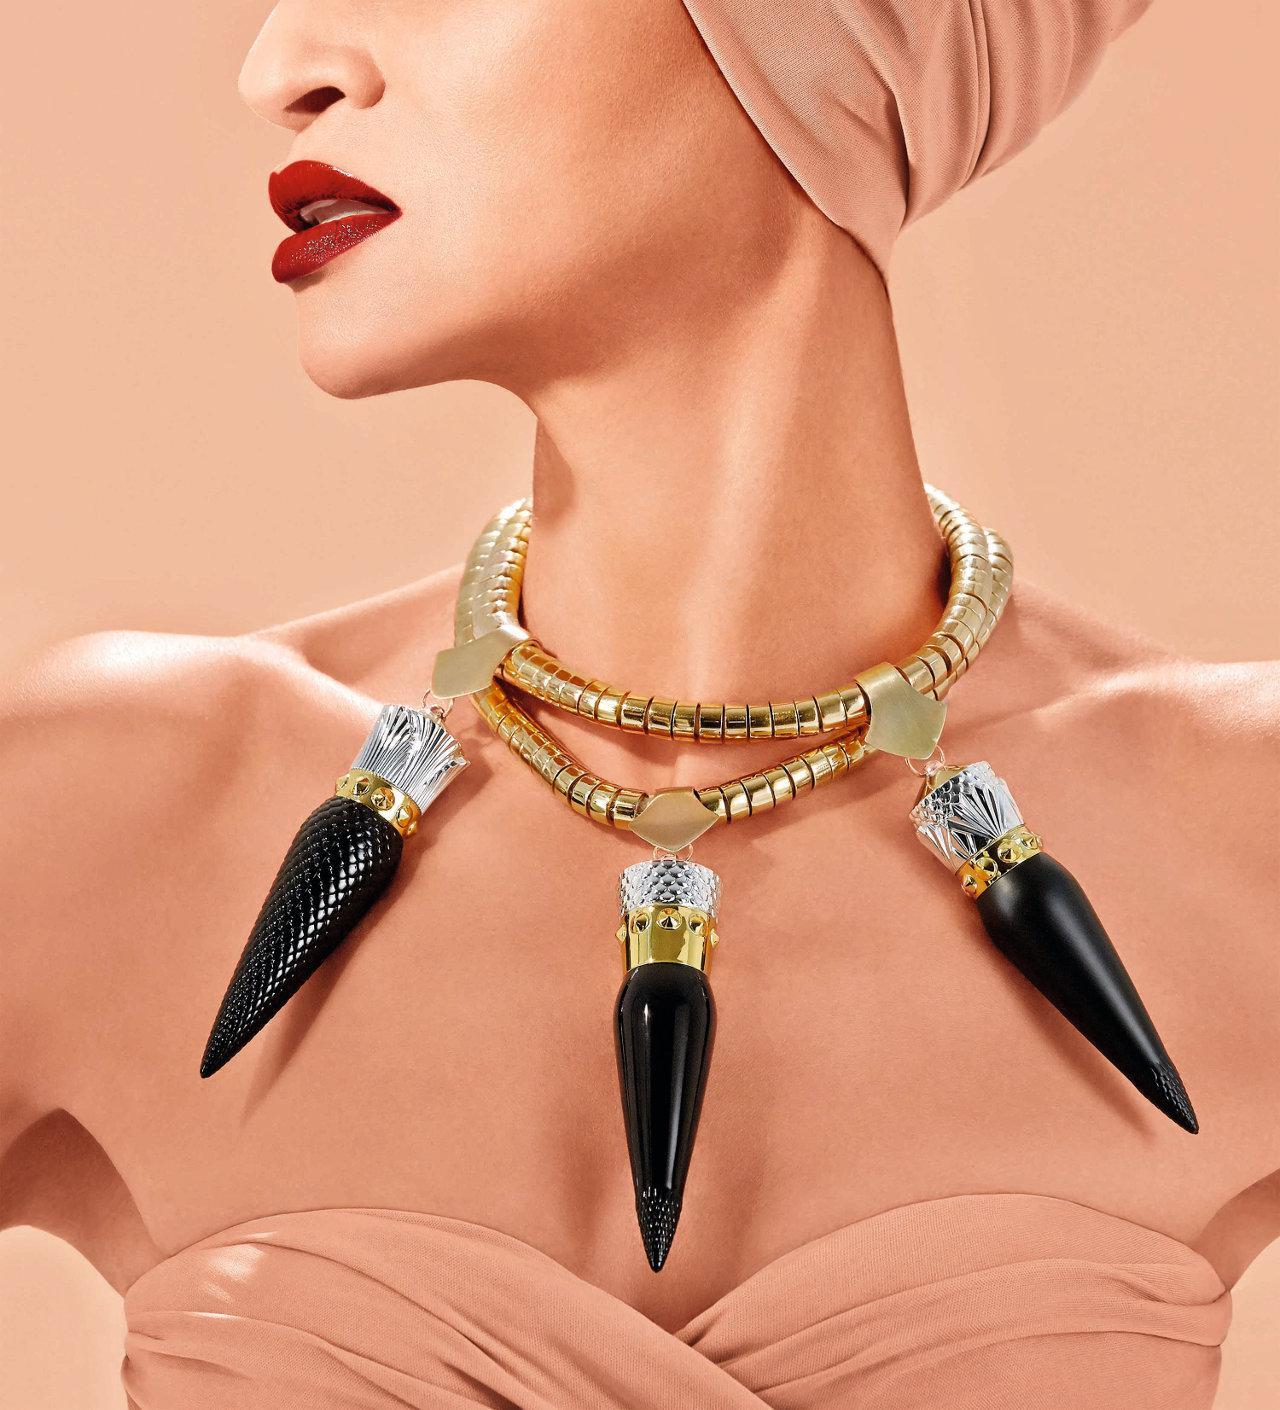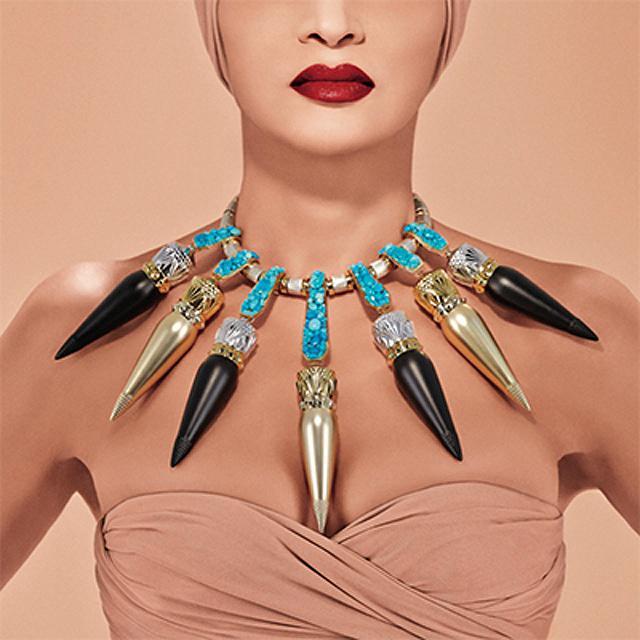The first image is the image on the left, the second image is the image on the right. Assess this claim about the two images: "An image shows untinted and tinted lips under the face of a smiling model.". Correct or not? Answer yes or no. No. The first image is the image on the left, the second image is the image on the right. Evaluate the accuracy of this statement regarding the images: "The right image contains a human wearing a large necklace.". Is it true? Answer yes or no. Yes. 